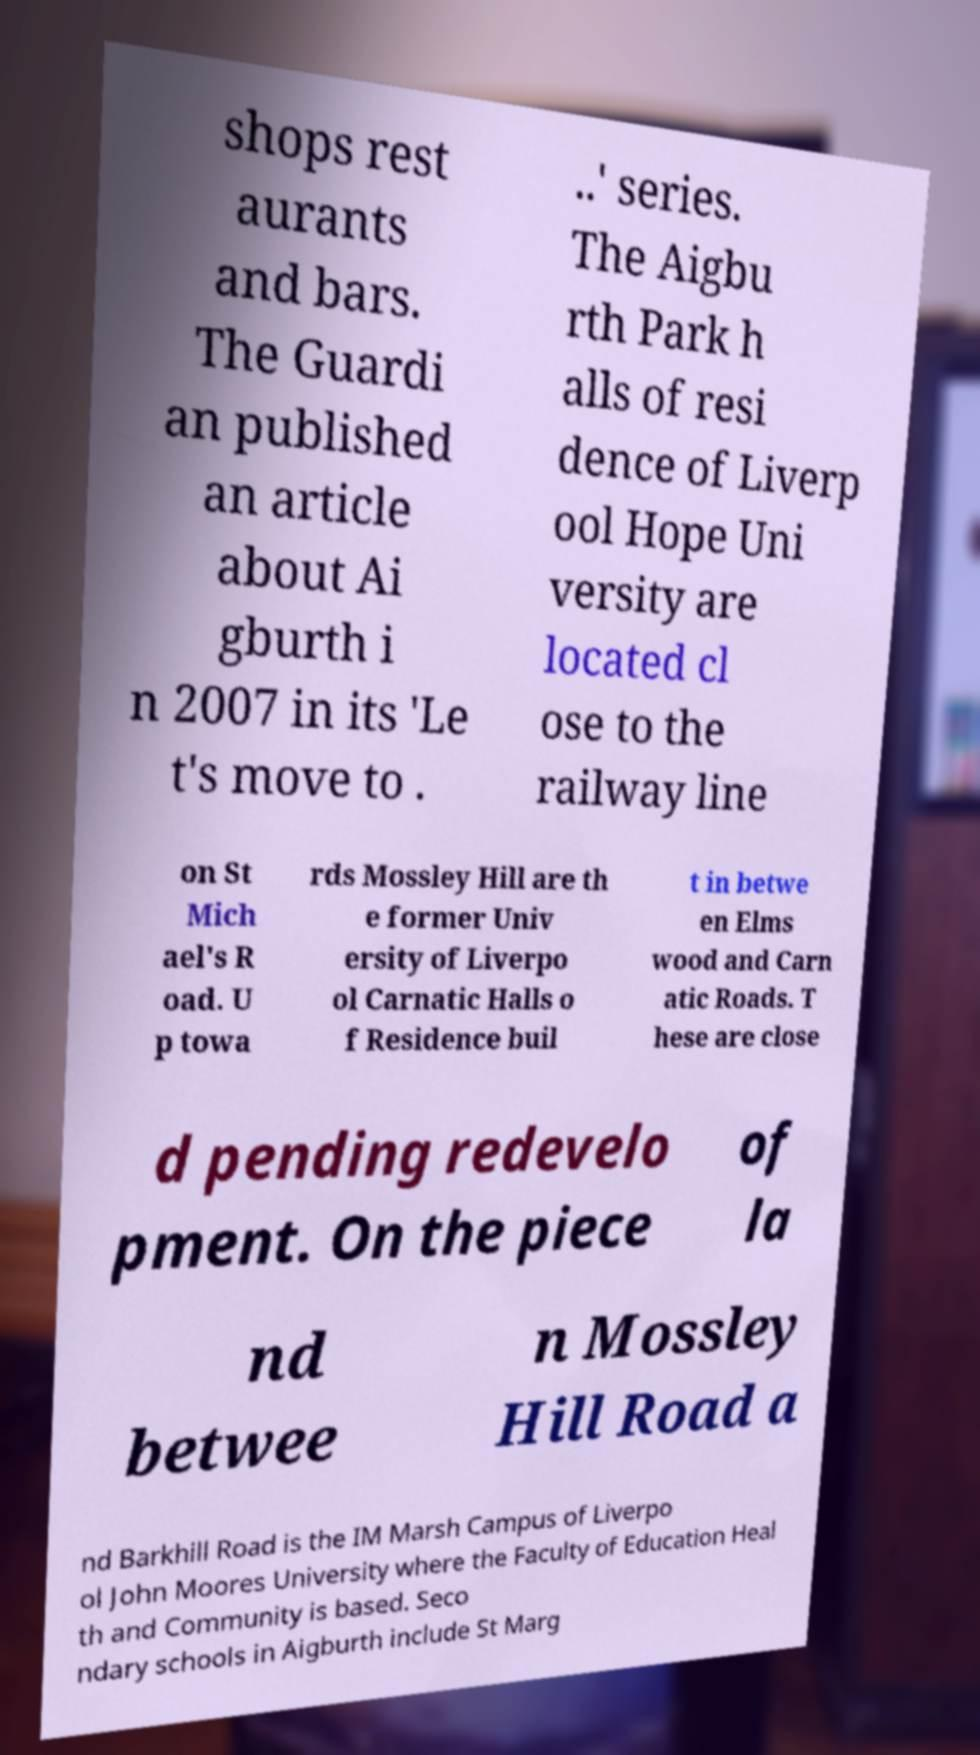Please read and relay the text visible in this image. What does it say? shops rest aurants and bars. The Guardi an published an article about Ai gburth i n 2007 in its 'Le t's move to . ..' series. The Aigbu rth Park h alls of resi dence of Liverp ool Hope Uni versity are located cl ose to the railway line on St Mich ael's R oad. U p towa rds Mossley Hill are th e former Univ ersity of Liverpo ol Carnatic Halls o f Residence buil t in betwe en Elms wood and Carn atic Roads. T hese are close d pending redevelo pment. On the piece of la nd betwee n Mossley Hill Road a nd Barkhill Road is the IM Marsh Campus of Liverpo ol John Moores University where the Faculty of Education Heal th and Community is based. Seco ndary schools in Aigburth include St Marg 